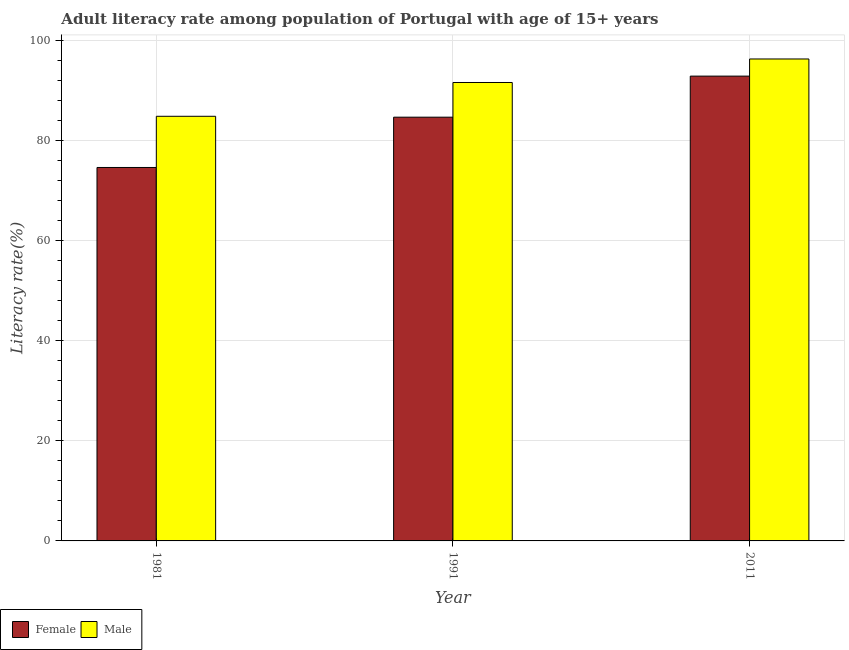How many different coloured bars are there?
Ensure brevity in your answer.  2. How many groups of bars are there?
Ensure brevity in your answer.  3. Are the number of bars per tick equal to the number of legend labels?
Provide a short and direct response. Yes. Are the number of bars on each tick of the X-axis equal?
Provide a short and direct response. Yes. How many bars are there on the 1st tick from the left?
Offer a very short reply. 2. How many bars are there on the 3rd tick from the right?
Your response must be concise. 2. What is the label of the 1st group of bars from the left?
Give a very brief answer. 1981. In how many cases, is the number of bars for a given year not equal to the number of legend labels?
Make the answer very short. 0. What is the female adult literacy rate in 1991?
Provide a succinct answer. 84.66. Across all years, what is the maximum female adult literacy rate?
Make the answer very short. 92.86. Across all years, what is the minimum female adult literacy rate?
Give a very brief answer. 74.61. In which year was the female adult literacy rate maximum?
Your response must be concise. 2011. What is the total female adult literacy rate in the graph?
Make the answer very short. 252.13. What is the difference between the female adult literacy rate in 1991 and that in 2011?
Give a very brief answer. -8.2. What is the difference between the female adult literacy rate in 2011 and the male adult literacy rate in 1991?
Offer a very short reply. 8.2. What is the average female adult literacy rate per year?
Offer a very short reply. 84.04. In the year 1981, what is the difference between the female adult literacy rate and male adult literacy rate?
Give a very brief answer. 0. In how many years, is the female adult literacy rate greater than 20 %?
Give a very brief answer. 3. What is the ratio of the female adult literacy rate in 1981 to that in 1991?
Your answer should be compact. 0.88. Is the difference between the female adult literacy rate in 1981 and 1991 greater than the difference between the male adult literacy rate in 1981 and 1991?
Ensure brevity in your answer.  No. What is the difference between the highest and the second highest female adult literacy rate?
Keep it short and to the point. 8.2. What is the difference between the highest and the lowest male adult literacy rate?
Ensure brevity in your answer.  11.45. In how many years, is the male adult literacy rate greater than the average male adult literacy rate taken over all years?
Your answer should be compact. 2. Is the sum of the female adult literacy rate in 1991 and 2011 greater than the maximum male adult literacy rate across all years?
Offer a terse response. Yes. What does the 2nd bar from the left in 1991 represents?
Your answer should be compact. Male. What does the 2nd bar from the right in 2011 represents?
Provide a short and direct response. Female. What is the difference between two consecutive major ticks on the Y-axis?
Provide a succinct answer. 20. Are the values on the major ticks of Y-axis written in scientific E-notation?
Give a very brief answer. No. Does the graph contain any zero values?
Provide a short and direct response. No. How many legend labels are there?
Offer a terse response. 2. What is the title of the graph?
Your answer should be very brief. Adult literacy rate among population of Portugal with age of 15+ years. What is the label or title of the Y-axis?
Provide a succinct answer. Literacy rate(%). What is the Literacy rate(%) of Female in 1981?
Your response must be concise. 74.61. What is the Literacy rate(%) in Male in 1981?
Offer a terse response. 84.83. What is the Literacy rate(%) in Female in 1991?
Offer a very short reply. 84.66. What is the Literacy rate(%) of Male in 1991?
Ensure brevity in your answer.  91.59. What is the Literacy rate(%) in Female in 2011?
Provide a succinct answer. 92.86. What is the Literacy rate(%) in Male in 2011?
Provide a succinct answer. 96.29. Across all years, what is the maximum Literacy rate(%) of Female?
Offer a very short reply. 92.86. Across all years, what is the maximum Literacy rate(%) of Male?
Your answer should be compact. 96.29. Across all years, what is the minimum Literacy rate(%) of Female?
Your response must be concise. 74.61. Across all years, what is the minimum Literacy rate(%) of Male?
Your response must be concise. 84.83. What is the total Literacy rate(%) in Female in the graph?
Offer a terse response. 252.13. What is the total Literacy rate(%) of Male in the graph?
Provide a succinct answer. 272.71. What is the difference between the Literacy rate(%) in Female in 1981 and that in 1991?
Provide a short and direct response. -10.05. What is the difference between the Literacy rate(%) in Male in 1981 and that in 1991?
Your response must be concise. -6.75. What is the difference between the Literacy rate(%) of Female in 1981 and that in 2011?
Keep it short and to the point. -18.25. What is the difference between the Literacy rate(%) of Male in 1981 and that in 2011?
Your answer should be very brief. -11.45. What is the difference between the Literacy rate(%) in Female in 1991 and that in 2011?
Your response must be concise. -8.2. What is the difference between the Literacy rate(%) in Male in 1991 and that in 2011?
Keep it short and to the point. -4.7. What is the difference between the Literacy rate(%) of Female in 1981 and the Literacy rate(%) of Male in 1991?
Keep it short and to the point. -16.98. What is the difference between the Literacy rate(%) of Female in 1981 and the Literacy rate(%) of Male in 2011?
Your response must be concise. -21.68. What is the difference between the Literacy rate(%) in Female in 1991 and the Literacy rate(%) in Male in 2011?
Offer a very short reply. -11.63. What is the average Literacy rate(%) of Female per year?
Provide a succinct answer. 84.04. What is the average Literacy rate(%) of Male per year?
Give a very brief answer. 90.9. In the year 1981, what is the difference between the Literacy rate(%) in Female and Literacy rate(%) in Male?
Offer a terse response. -10.23. In the year 1991, what is the difference between the Literacy rate(%) in Female and Literacy rate(%) in Male?
Give a very brief answer. -6.93. In the year 2011, what is the difference between the Literacy rate(%) in Female and Literacy rate(%) in Male?
Provide a short and direct response. -3.42. What is the ratio of the Literacy rate(%) in Female in 1981 to that in 1991?
Make the answer very short. 0.88. What is the ratio of the Literacy rate(%) of Male in 1981 to that in 1991?
Ensure brevity in your answer.  0.93. What is the ratio of the Literacy rate(%) in Female in 1981 to that in 2011?
Ensure brevity in your answer.  0.8. What is the ratio of the Literacy rate(%) of Male in 1981 to that in 2011?
Your response must be concise. 0.88. What is the ratio of the Literacy rate(%) in Female in 1991 to that in 2011?
Provide a succinct answer. 0.91. What is the ratio of the Literacy rate(%) in Male in 1991 to that in 2011?
Your answer should be very brief. 0.95. What is the difference between the highest and the second highest Literacy rate(%) of Female?
Provide a short and direct response. 8.2. What is the difference between the highest and the second highest Literacy rate(%) of Male?
Make the answer very short. 4.7. What is the difference between the highest and the lowest Literacy rate(%) of Female?
Provide a succinct answer. 18.25. What is the difference between the highest and the lowest Literacy rate(%) of Male?
Give a very brief answer. 11.45. 